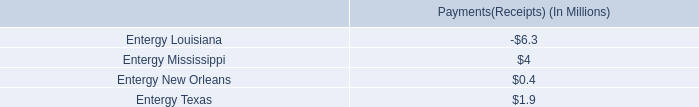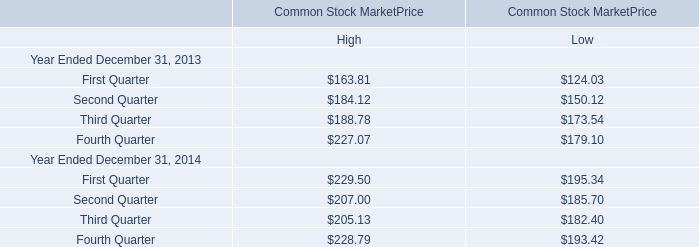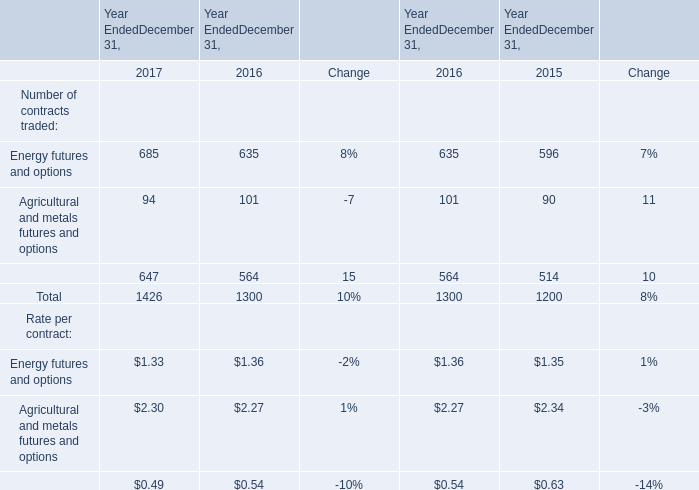When does the total number of contracts traded reach the largest amount? 
Answer: 2017. 